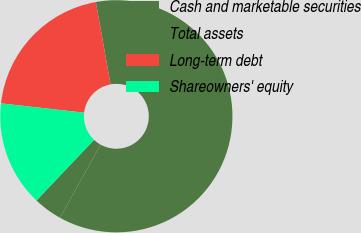Convert chart to OTSL. <chart><loc_0><loc_0><loc_500><loc_500><pie_chart><fcel>Cash and marketable securities<fcel>Total assets<fcel>Long-term debt<fcel>Shareowners' equity<nl><fcel>4.01%<fcel>60.9%<fcel>20.39%<fcel>14.7%<nl></chart> 